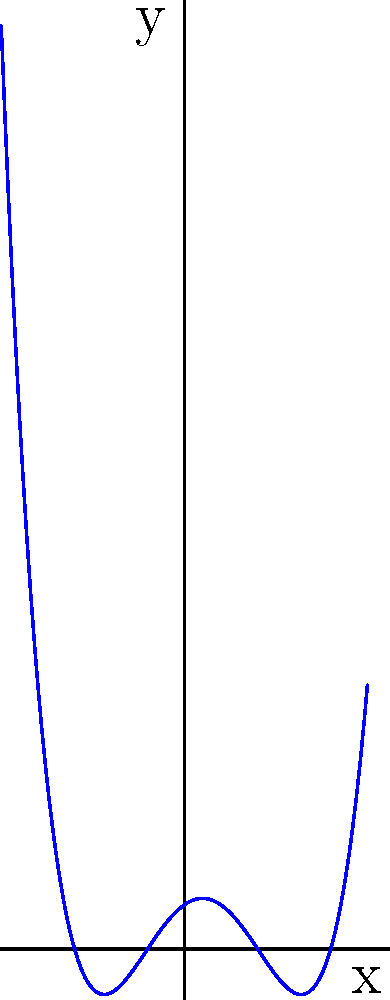As a union representative advocating for technology integration, you're analyzing data trends. The graph above represents a polynomial function modeling membership growth. Based on the graph's shape and behavior, what is the degree of this polynomial? To determine the degree of a polynomial from its graph, we need to consider the following steps:

1. Count the number of turning points (local maxima and minima):
   In this graph, we can see 3 turning points.

2. Count the number of x-intercepts (roots):
   The graph crosses the x-axis 4 times.

3. Observe the end behavior:
   As x approaches positive and negative infinity, y approaches positive infinity.

4. Apply the degree determination rules:
   - The degree is at least one more than the number of turning points.
   - The degree is at most equal to the number of x-intercepts.
   - For even degree polynomials, the end behavior is the same for both positive and negative x.
   - For odd degree polynomials, the end behavior is opposite for positive and negative x.

5. Conclusion:
   Given 3 turning points, the degree must be at least 4.
   With 4 x-intercepts, the degree can be at most 4.
   The end behavior suggests an even degree.

Therefore, the only degree that satisfies all these conditions is 4.
Answer: 4 